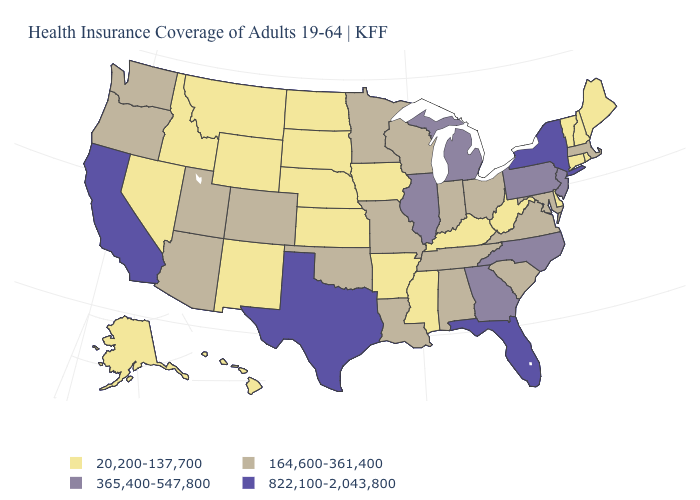Name the states that have a value in the range 164,600-361,400?
Short answer required. Alabama, Arizona, Colorado, Indiana, Louisiana, Maryland, Massachusetts, Minnesota, Missouri, Ohio, Oklahoma, Oregon, South Carolina, Tennessee, Utah, Virginia, Washington, Wisconsin. What is the value of New Jersey?
Be succinct. 365,400-547,800. What is the value of Indiana?
Write a very short answer. 164,600-361,400. Name the states that have a value in the range 20,200-137,700?
Keep it brief. Alaska, Arkansas, Connecticut, Delaware, Hawaii, Idaho, Iowa, Kansas, Kentucky, Maine, Mississippi, Montana, Nebraska, Nevada, New Hampshire, New Mexico, North Dakota, Rhode Island, South Dakota, Vermont, West Virginia, Wyoming. What is the lowest value in the South?
Short answer required. 20,200-137,700. Name the states that have a value in the range 365,400-547,800?
Give a very brief answer. Georgia, Illinois, Michigan, New Jersey, North Carolina, Pennsylvania. Name the states that have a value in the range 164,600-361,400?
Short answer required. Alabama, Arizona, Colorado, Indiana, Louisiana, Maryland, Massachusetts, Minnesota, Missouri, Ohio, Oklahoma, Oregon, South Carolina, Tennessee, Utah, Virginia, Washington, Wisconsin. Which states have the lowest value in the USA?
Concise answer only. Alaska, Arkansas, Connecticut, Delaware, Hawaii, Idaho, Iowa, Kansas, Kentucky, Maine, Mississippi, Montana, Nebraska, Nevada, New Hampshire, New Mexico, North Dakota, Rhode Island, South Dakota, Vermont, West Virginia, Wyoming. Name the states that have a value in the range 20,200-137,700?
Be succinct. Alaska, Arkansas, Connecticut, Delaware, Hawaii, Idaho, Iowa, Kansas, Kentucky, Maine, Mississippi, Montana, Nebraska, Nevada, New Hampshire, New Mexico, North Dakota, Rhode Island, South Dakota, Vermont, West Virginia, Wyoming. Name the states that have a value in the range 164,600-361,400?
Write a very short answer. Alabama, Arizona, Colorado, Indiana, Louisiana, Maryland, Massachusetts, Minnesota, Missouri, Ohio, Oklahoma, Oregon, South Carolina, Tennessee, Utah, Virginia, Washington, Wisconsin. What is the value of North Dakota?
Keep it brief. 20,200-137,700. Does New York have the highest value in the USA?
Keep it brief. Yes. Name the states that have a value in the range 164,600-361,400?
Concise answer only. Alabama, Arizona, Colorado, Indiana, Louisiana, Maryland, Massachusetts, Minnesota, Missouri, Ohio, Oklahoma, Oregon, South Carolina, Tennessee, Utah, Virginia, Washington, Wisconsin. Name the states that have a value in the range 164,600-361,400?
Answer briefly. Alabama, Arizona, Colorado, Indiana, Louisiana, Maryland, Massachusetts, Minnesota, Missouri, Ohio, Oklahoma, Oregon, South Carolina, Tennessee, Utah, Virginia, Washington, Wisconsin. Which states have the lowest value in the USA?
Concise answer only. Alaska, Arkansas, Connecticut, Delaware, Hawaii, Idaho, Iowa, Kansas, Kentucky, Maine, Mississippi, Montana, Nebraska, Nevada, New Hampshire, New Mexico, North Dakota, Rhode Island, South Dakota, Vermont, West Virginia, Wyoming. 